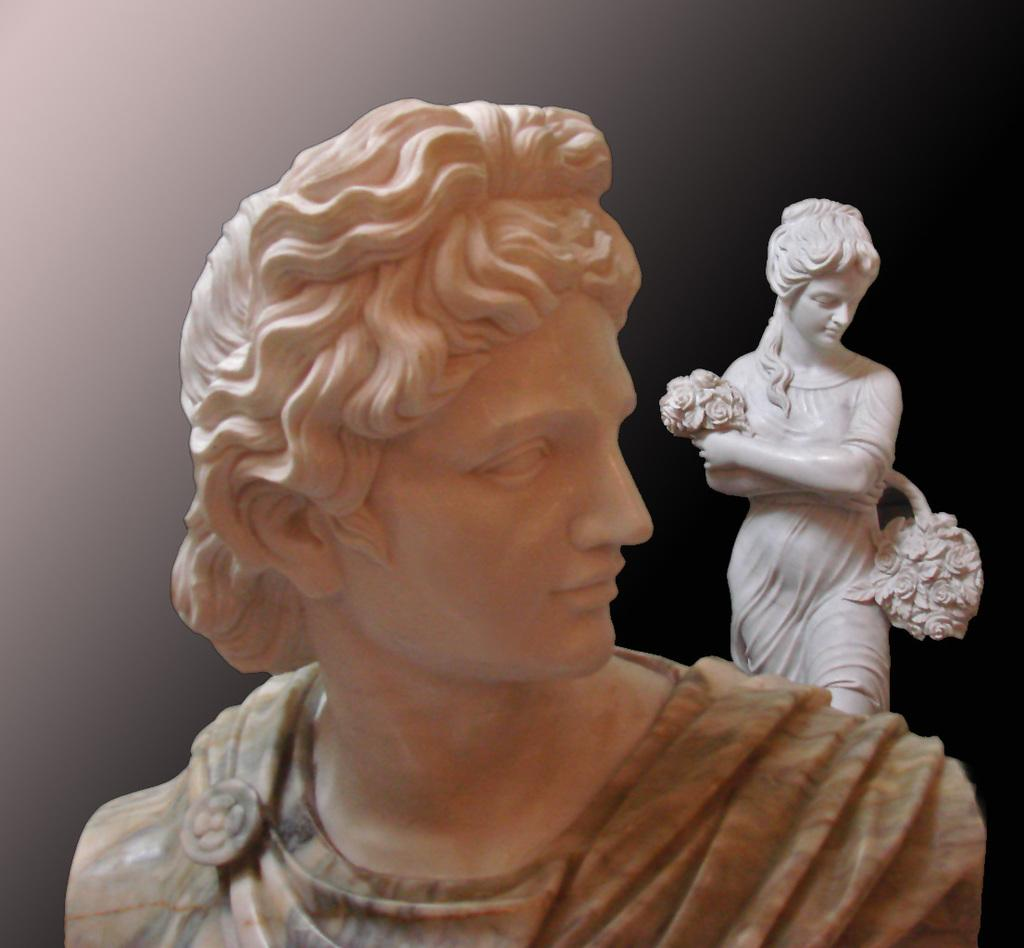What is the main subject in the foreground of the image? There is a sculpture in the foreground of the image. Can you describe the background of the image? The background of the image is blurred. Are there any other sculptures visible in the image? Yes, there is another sculpture in the background of the image. What type of underwear can be seen hanging on the sculpture in the background? There is no underwear present in the picture, let alone hanging on a sculpture. 